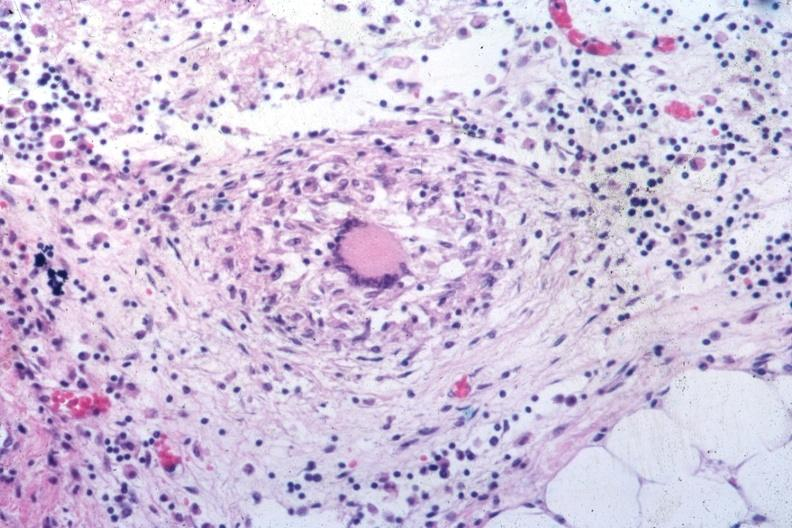s tuberculous peritonitis present?
Answer the question using a single word or phrase. No 